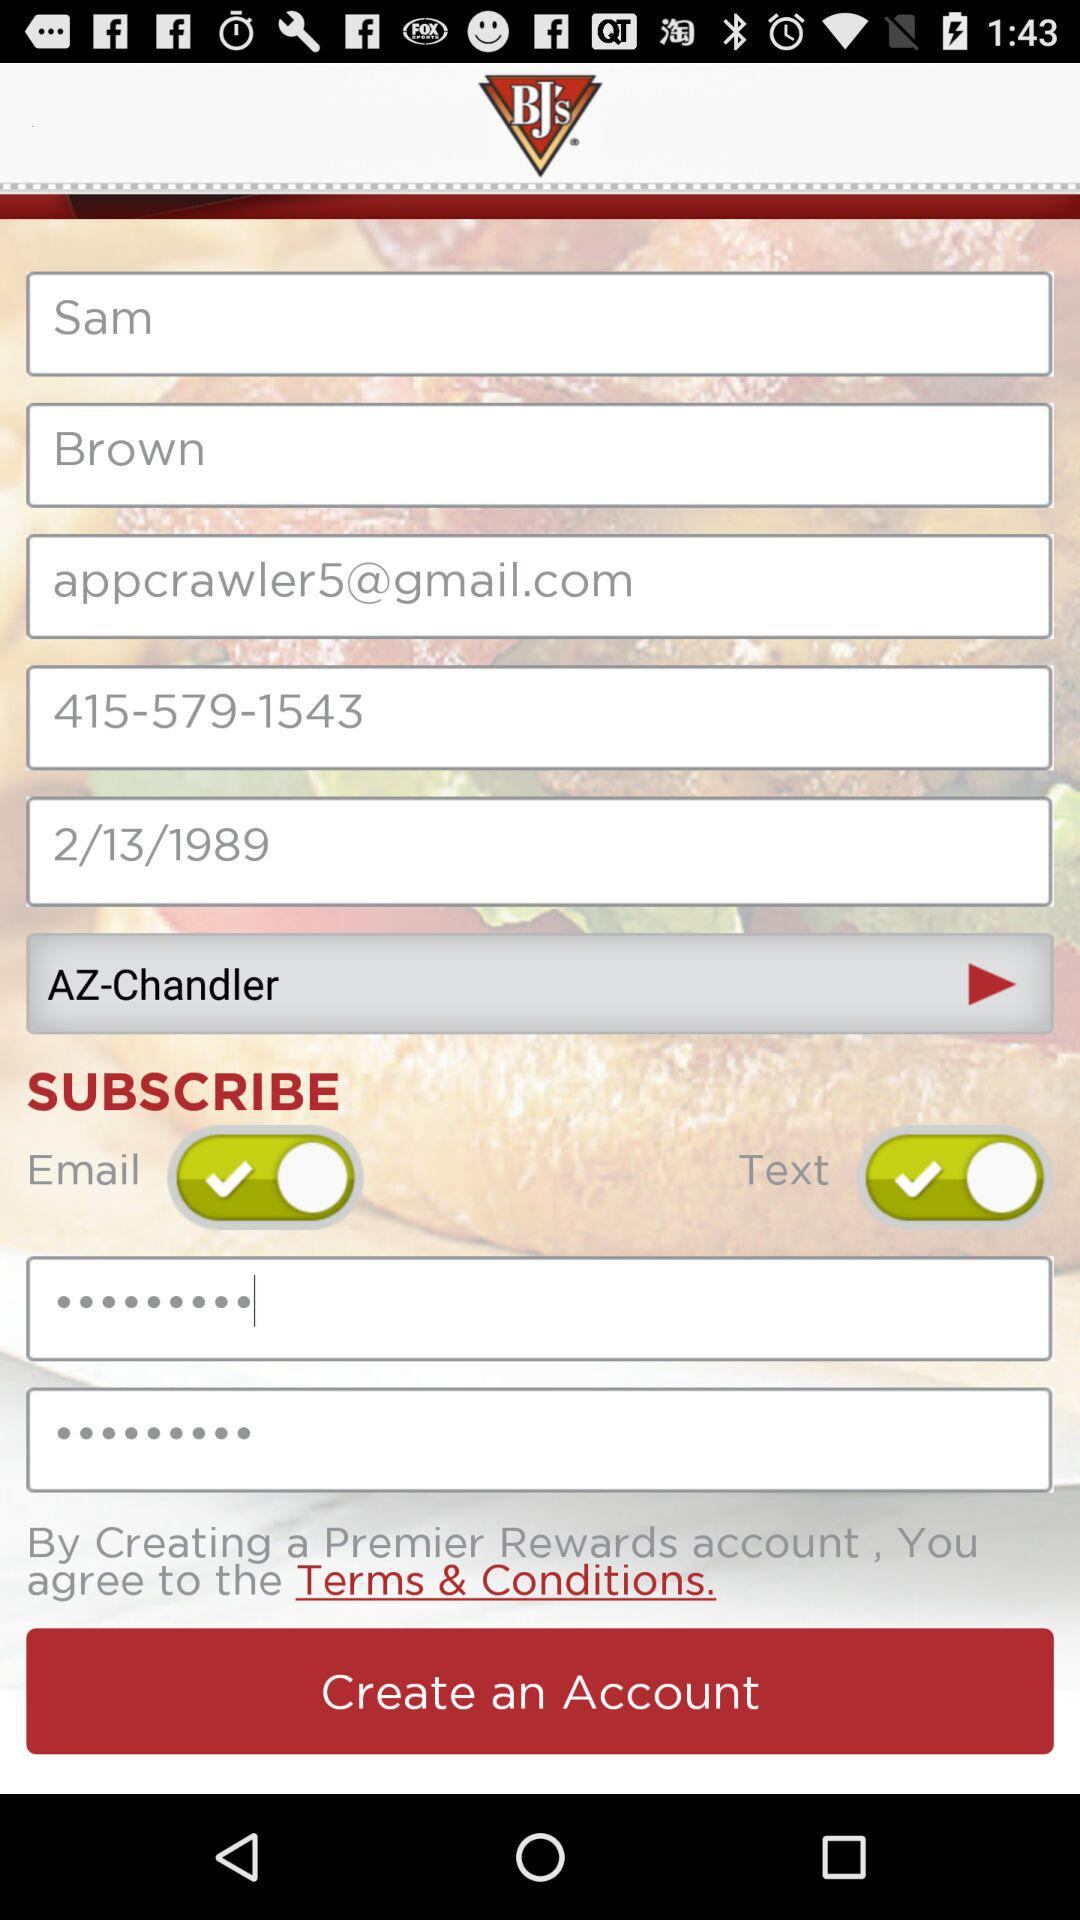What is the last name? The last name is Brown. 